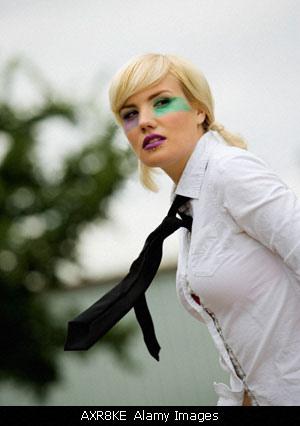What color is her eye shadow?
Answer briefly. Green. Does the woman have brown hair?
Write a very short answer. No. Is this woman a model?
Quick response, please. Yes. 